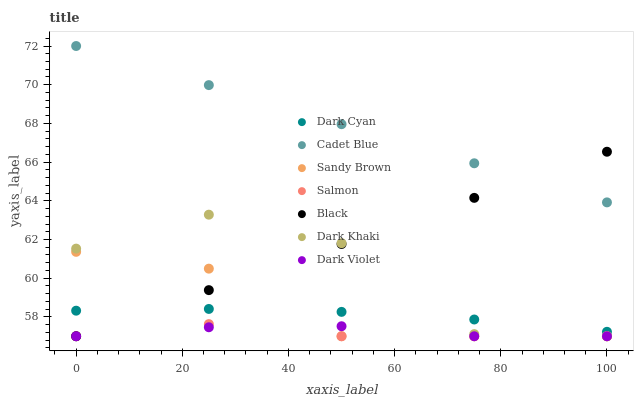Does Salmon have the minimum area under the curve?
Answer yes or no. Yes. Does Cadet Blue have the maximum area under the curve?
Answer yes or no. Yes. Does Dark Violet have the minimum area under the curve?
Answer yes or no. No. Does Dark Violet have the maximum area under the curve?
Answer yes or no. No. Is Black the smoothest?
Answer yes or no. Yes. Is Dark Khaki the roughest?
Answer yes or no. Yes. Is Salmon the smoothest?
Answer yes or no. No. Is Salmon the roughest?
Answer yes or no. No. Does Salmon have the lowest value?
Answer yes or no. Yes. Does Dark Cyan have the lowest value?
Answer yes or no. No. Does Cadet Blue have the highest value?
Answer yes or no. Yes. Does Salmon have the highest value?
Answer yes or no. No. Is Dark Khaki less than Cadet Blue?
Answer yes or no. Yes. Is Dark Cyan greater than Dark Violet?
Answer yes or no. Yes. Does Salmon intersect Dark Violet?
Answer yes or no. Yes. Is Salmon less than Dark Violet?
Answer yes or no. No. Is Salmon greater than Dark Violet?
Answer yes or no. No. Does Dark Khaki intersect Cadet Blue?
Answer yes or no. No. 